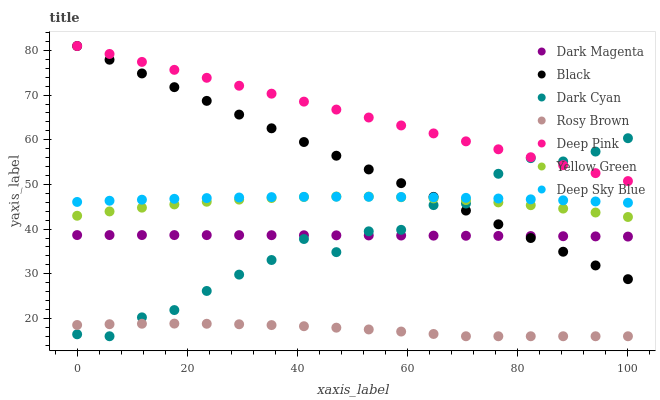Does Rosy Brown have the minimum area under the curve?
Answer yes or no. Yes. Does Deep Pink have the maximum area under the curve?
Answer yes or no. Yes. Does Dark Magenta have the minimum area under the curve?
Answer yes or no. No. Does Dark Magenta have the maximum area under the curve?
Answer yes or no. No. Is Black the smoothest?
Answer yes or no. Yes. Is Dark Cyan the roughest?
Answer yes or no. Yes. Is Dark Magenta the smoothest?
Answer yes or no. No. Is Dark Magenta the roughest?
Answer yes or no. No. Does Rosy Brown have the lowest value?
Answer yes or no. Yes. Does Dark Magenta have the lowest value?
Answer yes or no. No. Does Black have the highest value?
Answer yes or no. Yes. Does Dark Magenta have the highest value?
Answer yes or no. No. Is Rosy Brown less than Deep Pink?
Answer yes or no. Yes. Is Black greater than Rosy Brown?
Answer yes or no. Yes. Does Black intersect Dark Magenta?
Answer yes or no. Yes. Is Black less than Dark Magenta?
Answer yes or no. No. Is Black greater than Dark Magenta?
Answer yes or no. No. Does Rosy Brown intersect Deep Pink?
Answer yes or no. No. 